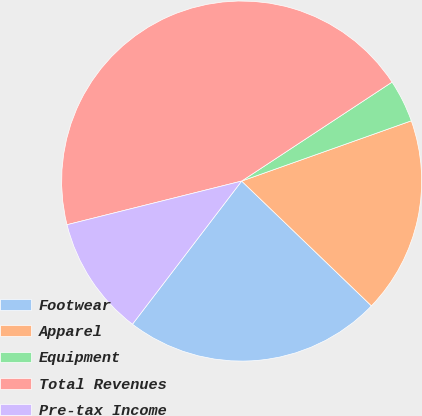<chart> <loc_0><loc_0><loc_500><loc_500><pie_chart><fcel>Footwear<fcel>Apparel<fcel>Equipment<fcel>Total Revenues<fcel>Pre-tax Income<nl><fcel>23.18%<fcel>17.62%<fcel>3.83%<fcel>44.63%<fcel>10.73%<nl></chart> 